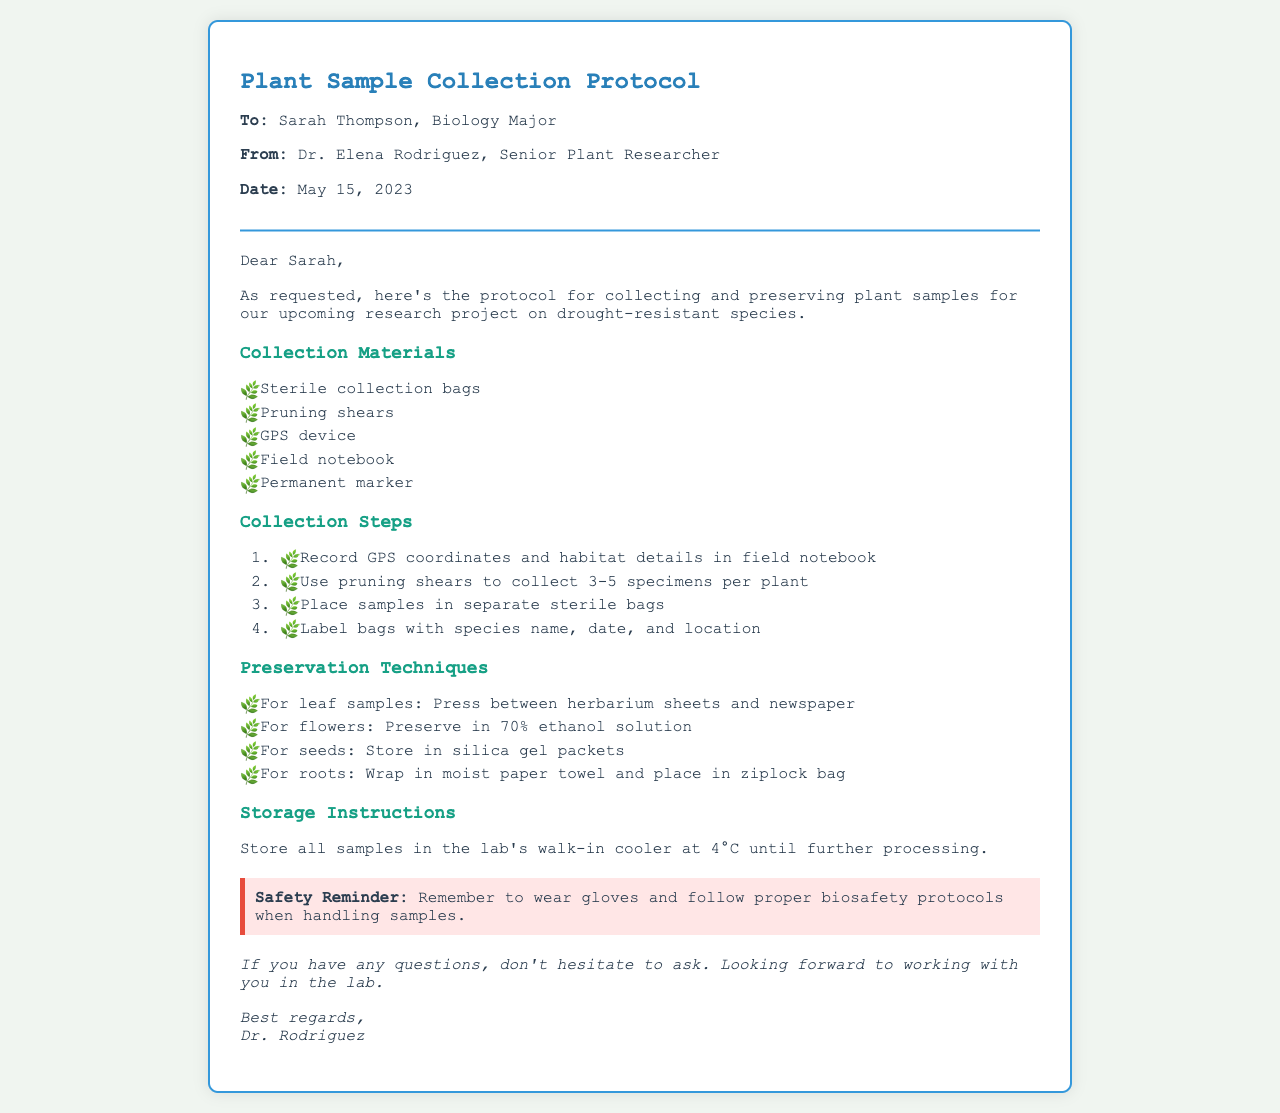what is the date of the protocol? The date of the protocol is mentioned explicitly in the document, which is May 15, 2023.
Answer: May 15, 2023 who is the sender of the fax? The sender of the fax is identified in the header of the document as Dr. Elena Rodriguez.
Answer: Dr. Elena Rodriguez how many specimens should be collected per plant? The document specifies that 3-5 specimens should be collected per plant.
Answer: 3-5 specimens which solution is used to preserve flowers? The preservation technique for flowers is explicitly detailed as using a 70% ethanol solution.
Answer: 70% ethanol solution what temperature should samples be stored at? The storage instructions provide the temperature at which samples should be kept, which is 4°C.
Answer: 4°C what is one of the materials listed for collection? The document lists several collection materials; one example is sterile collection bags.
Answer: sterile collection bags what type of sample is preserved with silica gel? The document specifies that seeds should be stored in silica gel packets.
Answer: seeds what should be wrapped in moist paper towel? The preservation instructions mention wrapping roots in a moist paper towel.
Answer: roots what is the primary purpose of the document? The document aims to provide a protocol for collecting and preserving plant samples for a specific research project.
Answer: protocol for collecting and preserving plant samples 